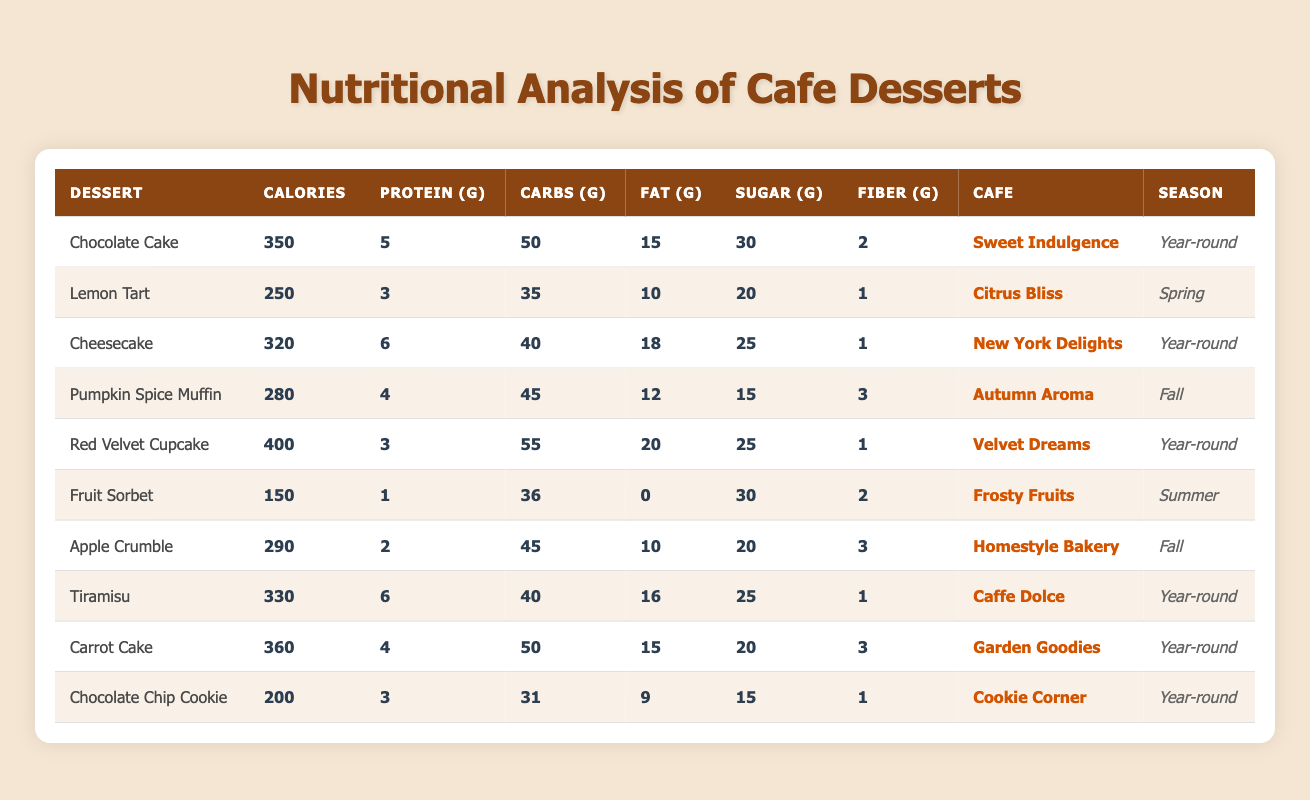What is the total calorie count of the desserts offered in the "Year-round" season? The desserts available year-round are Chocolate Cake (350), Cheesecake (320), Red Velvet Cupcake (400), Tiramisu (330), Carrot Cake (360), and Chocolate Chip Cookie (200). Adding these values gives: 350 + 320 + 400 + 330 + 360 + 200 = 1960.
Answer: 1960 Which dessert contains the highest amount of sugar? Checking the sugar values from the table, Red Velvet Cupcake, Chocolate Cake, Cheesecake, Tiramisu, and Carrot Cake each have 25g of sugar, while Lemon Tart has 20g, Pumpkin Spice Muffin has 15g, Apple Crumble has 20g, and Fruit Sorbet has 30g. Fruit Sorbet has the highest sugar content at 30g.
Answer: Fruit Sorbet Is Lemon Tart a dessert that can be enjoyed year-round? The table lists Lemon Tart with a season of Spring, indicating it's not available year-round. Therefore, the statement is false.
Answer: No What is the average protein content of the desserts excluding the "Year-round" options? The desserts not available year-round are Lemon Tart (3g), Pumpkin Spice Muffin (4g), Fruit Sorbet (1g), Apple Crumble (2g). The total protein for these desserts is 3 + 4 + 1 + 2 = 10g. There are 4 desserts, so the average is 10/4 = 2.5g.
Answer: 2.5 Which dessert has the lowest calorie count and what cafe offers it? Looking through the calorie values, Fruit Sorbet has the lowest at 150 calories and it is offered at Frosty Fruits.
Answer: Fruit Sorbet, Frosty Fruits What is the combined fat content of the Chocolate Cake and Red Velvet Cupcake? The fat content of Chocolate Cake is 15g and Red Velvet Cupcake is 20g. Adding these values gives: 15 + 20 = 35g of fat.
Answer: 35 How many desserts contain more than 30g of carbohydrates? The desserts with more than 30g of carbohydrates are Chocolate Cake (50g), Cheesecake (40g), Pumpkin Spice Muffin (45g), Red Velvet Cupcake (55g), and Carrot Cake (50g). Therefore, there are 5 desserts that meet this criterion.
Answer: 5 What is the difference in calorie content between the highest and lowest calorie dessert? The highest calorie dessert is Red Velvet Cupcake with 400 calories and the lowest is Fruit Sorbet with 150 calories. The difference is: 400 - 150 = 250 calories.
Answer: 250 Which cafe offers the most seasonal desserts according to the data? The Year-round desserts are six (6), and Fall has two (2) desserts (Pumpkin Spice Muffin and Apple Crumble), while Spring and Summer have one (1) dessert each (Lemon Tart and Fruit Sorbet). Therefore, “Year-round” offers the most desserts.
Answer: Year-round Is the average fiber content of desserts from "Caffe Dolce" higher than the average fiber content of desserts from "Cookie Corner"? The fiber content from Caffe Dolce (Tiramisu) is 1g. The fiber content from Cookie Corner (Chocolate Chip Cookie) is also 1g. Thus, the average fiber content from both cafes is equal (1g). Therefore, the statement is false.
Answer: No 